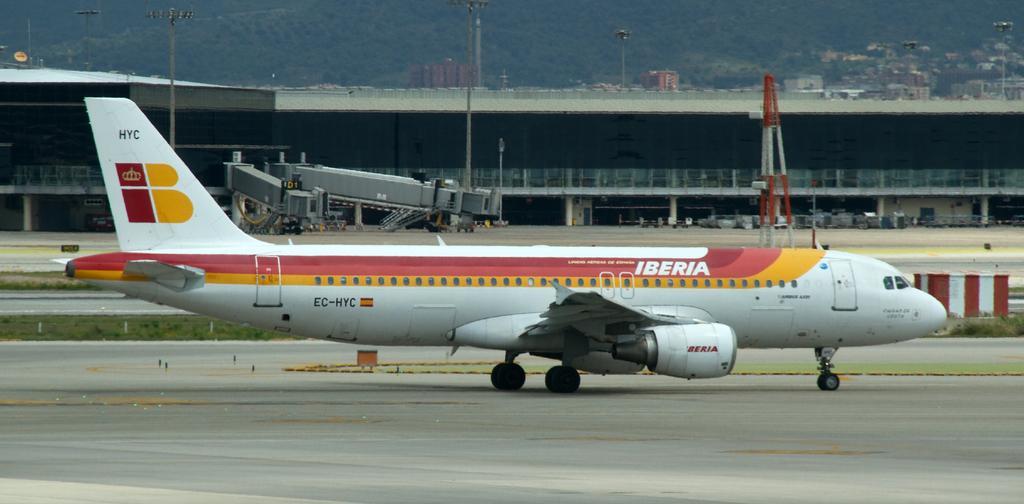Describe this image in one or two sentences. In this picture we can see an airplane in the front, on the right side there is grass, in the background we can see buildings, poles and trees, there is railing in the middle. 